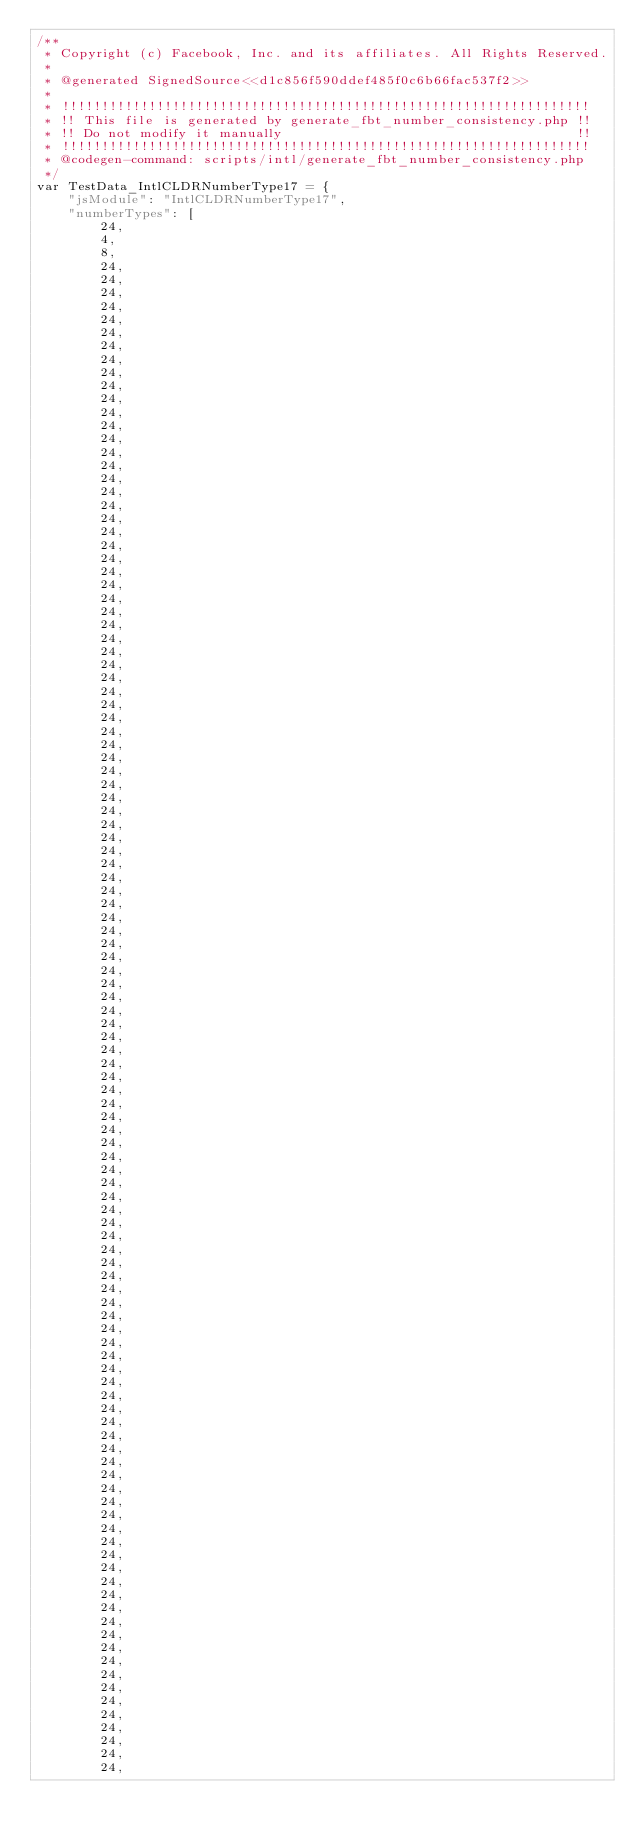Convert code to text. <code><loc_0><loc_0><loc_500><loc_500><_JavaScript_>/**
 * Copyright (c) Facebook, Inc. and its affiliates. All Rights Reserved.
 *
 * @generated SignedSource<<d1c856f590ddef485f0c6b66fac537f2>>
 *
 * !!!!!!!!!!!!!!!!!!!!!!!!!!!!!!!!!!!!!!!!!!!!!!!!!!!!!!!!!!!!!!!!!!!
 * !! This file is generated by generate_fbt_number_consistency.php !!
 * !! Do not modify it manually                                     !!
 * !!!!!!!!!!!!!!!!!!!!!!!!!!!!!!!!!!!!!!!!!!!!!!!!!!!!!!!!!!!!!!!!!!!
 * @codegen-command: scripts/intl/generate_fbt_number_consistency.php
 */
var TestData_IntlCLDRNumberType17 = {
    "jsModule": "IntlCLDRNumberType17",
    "numberTypes": [
        24,
        4,
        8,
        24,
        24,
        24,
        24,
        24,
        24,
        24,
        24,
        24,
        24,
        24,
        24,
        24,
        24,
        24,
        24,
        24,
        24,
        24,
        24,
        24,
        24,
        24,
        24,
        24,
        24,
        24,
        24,
        24,
        24,
        24,
        24,
        24,
        24,
        24,
        24,
        24,
        24,
        24,
        24,
        24,
        24,
        24,
        24,
        24,
        24,
        24,
        24,
        24,
        24,
        24,
        24,
        24,
        24,
        24,
        24,
        24,
        24,
        24,
        24,
        24,
        24,
        24,
        24,
        24,
        24,
        24,
        24,
        24,
        24,
        24,
        24,
        24,
        24,
        24,
        24,
        24,
        24,
        24,
        24,
        24,
        24,
        24,
        24,
        24,
        24,
        24,
        24,
        24,
        24,
        24,
        24,
        24,
        24,
        24,
        24,
        24,
        24,
        24,
        24,
        24,
        24,
        24,
        24,
        24,
        24,
        24,
        24,
        24,
        24,
        24,
        24,
        24,
        24,</code> 